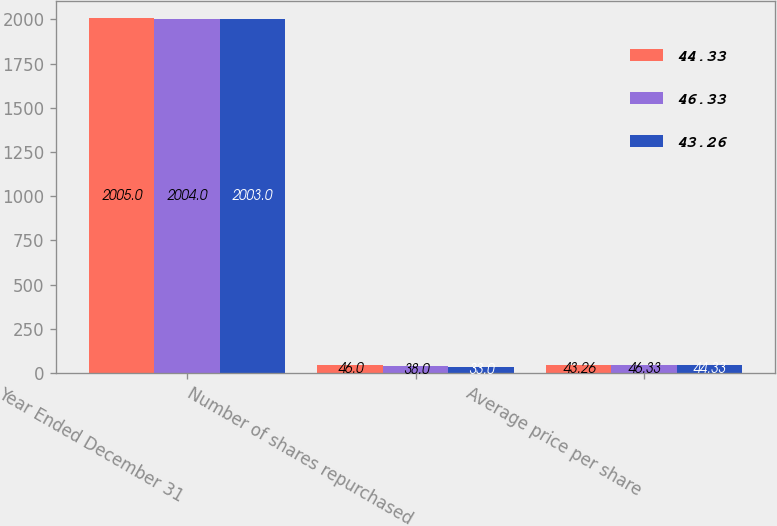<chart> <loc_0><loc_0><loc_500><loc_500><stacked_bar_chart><ecel><fcel>Year Ended December 31<fcel>Number of shares repurchased<fcel>Average price per share<nl><fcel>44.33<fcel>2005<fcel>46<fcel>43.26<nl><fcel>46.33<fcel>2004<fcel>38<fcel>46.33<nl><fcel>43.26<fcel>2003<fcel>33<fcel>44.33<nl></chart> 